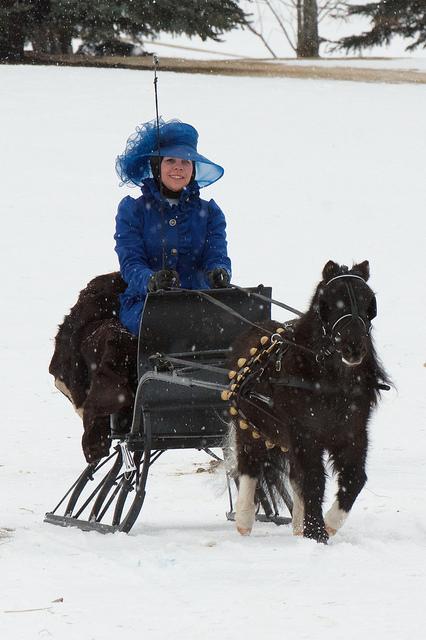What is another name for this woman's style of hat?
Be succinct. Fancy. Is she being pulled by a full size horse?
Be succinct. No. Is the woman rich?
Write a very short answer. Yes. 